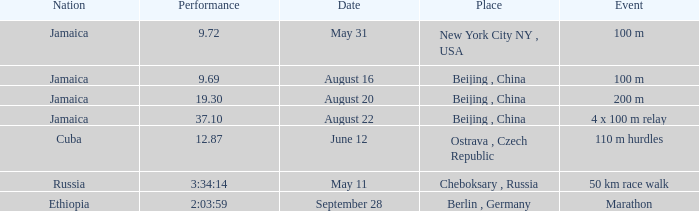What is the Place associated with Cuba? Ostrava , Czech Republic. 